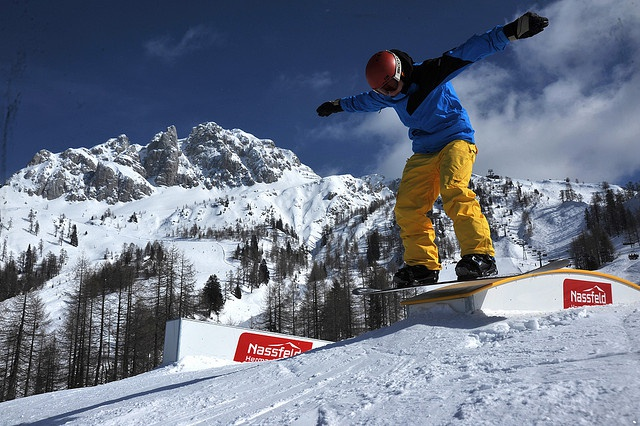Describe the objects in this image and their specific colors. I can see people in navy, black, olive, and maroon tones and snowboard in navy, black, gray, lightgray, and darkgray tones in this image. 